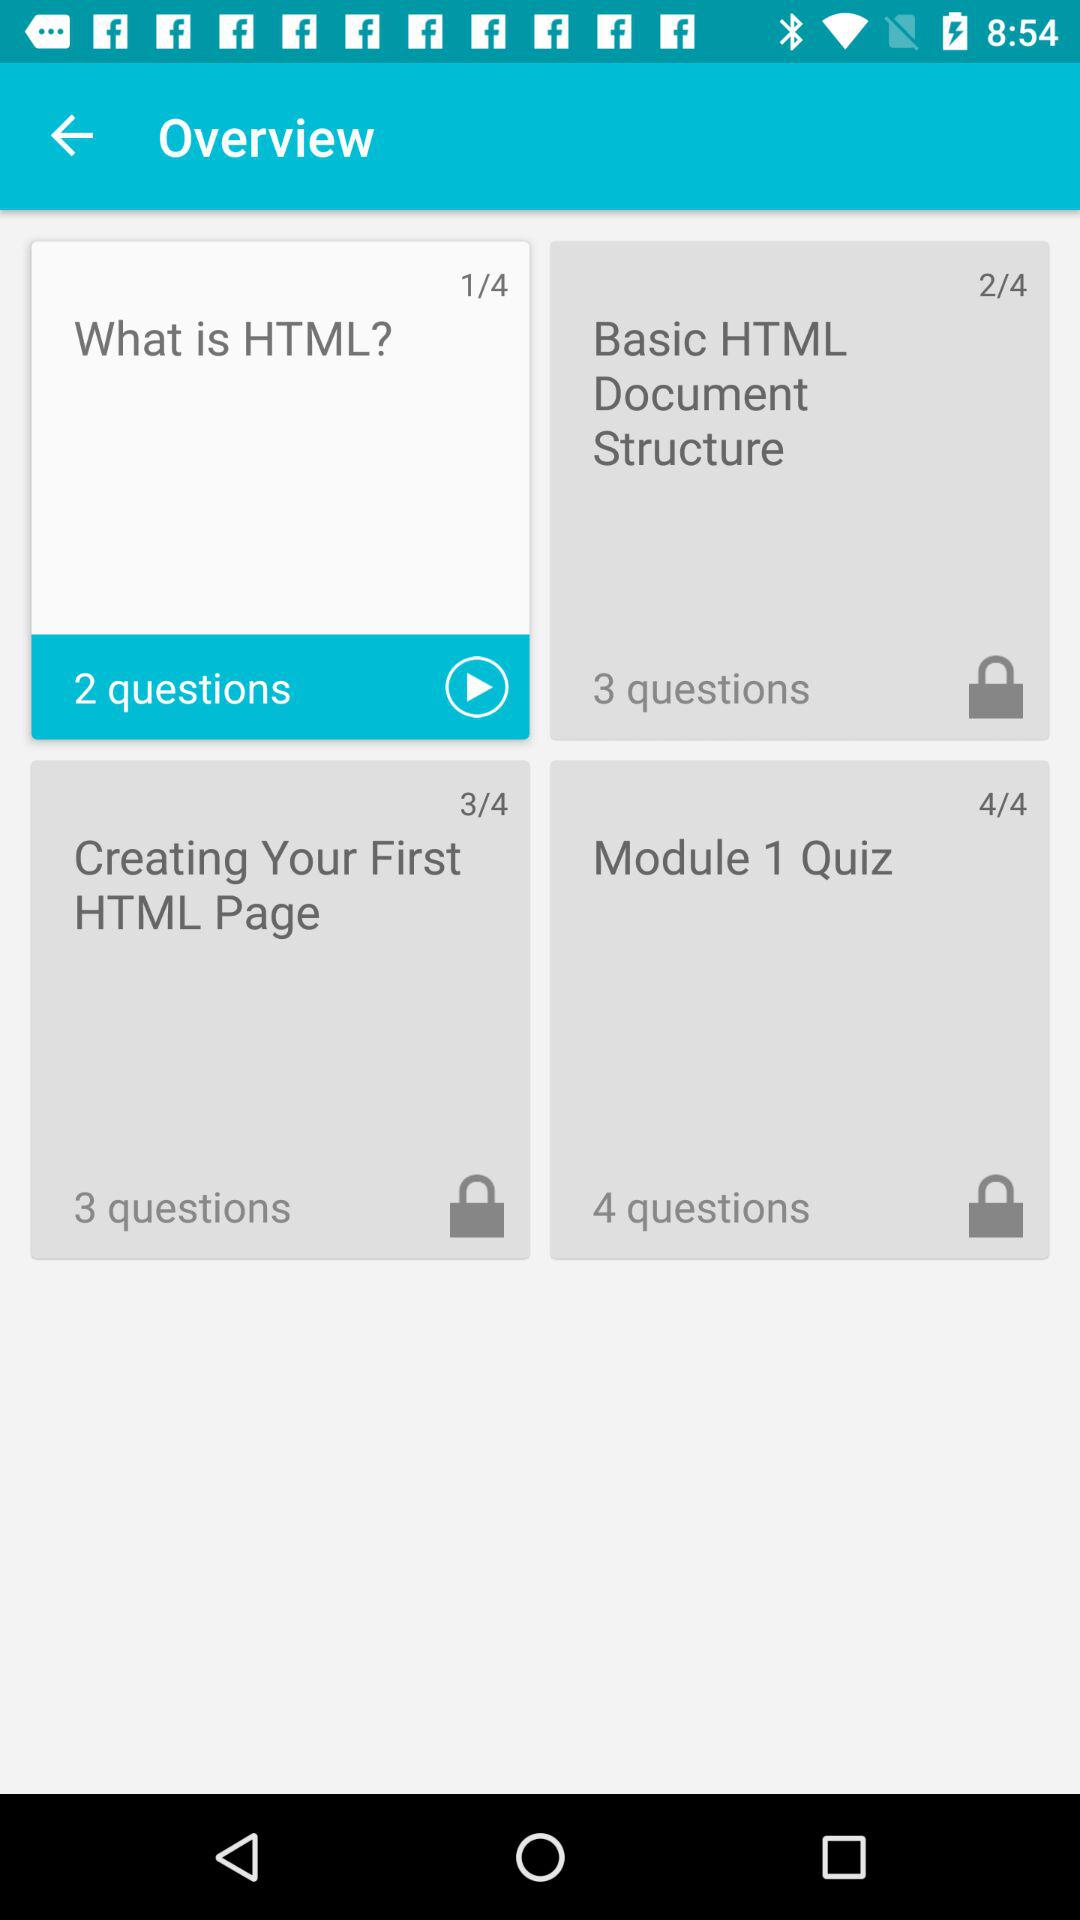How many questions does "Creating Your First HTML Page" have? There are 3 questions. 